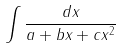Convert formula to latex. <formula><loc_0><loc_0><loc_500><loc_500>\int \frac { d x } { a + b x + c x ^ { 2 } }</formula> 